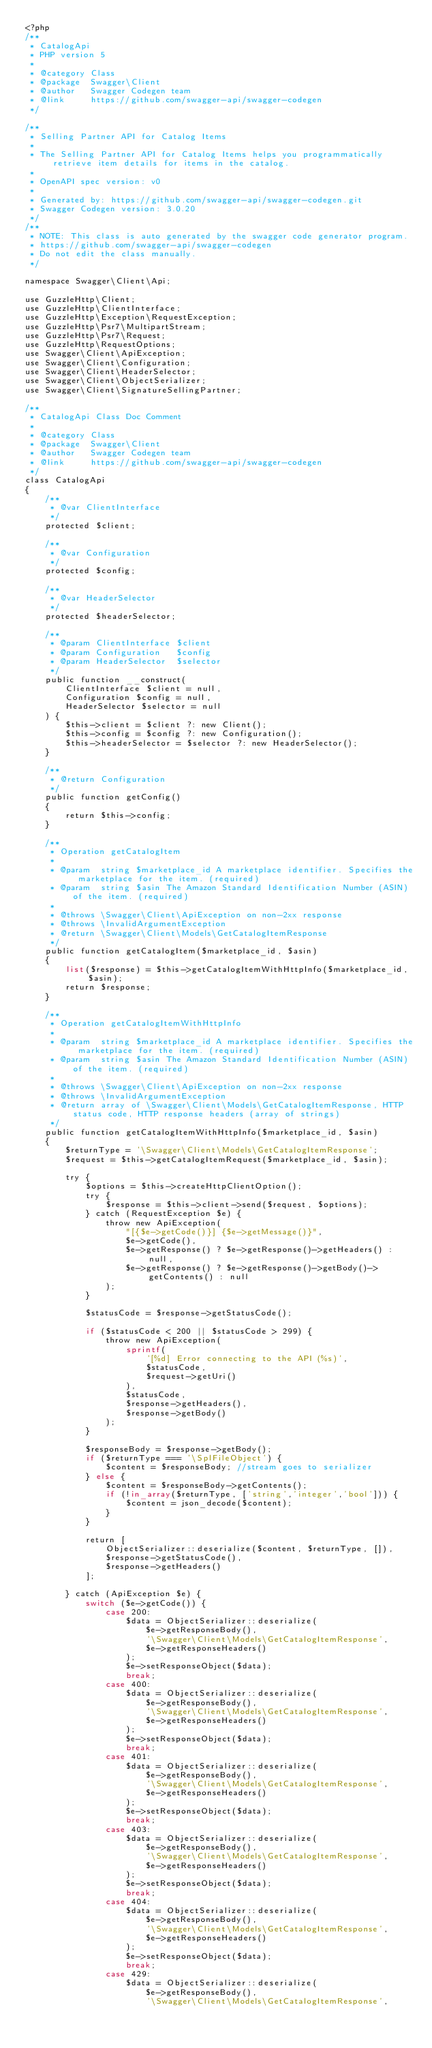Convert code to text. <code><loc_0><loc_0><loc_500><loc_500><_PHP_><?php
/**
 * CatalogApi
 * PHP version 5
 *
 * @category Class
 * @package  Swagger\Client
 * @author   Swagger Codegen team
 * @link     https://github.com/swagger-api/swagger-codegen
 */

/**
 * Selling Partner API for Catalog Items
 *
 * The Selling Partner API for Catalog Items helps you programmatically retrieve item details for items in the catalog.
 *
 * OpenAPI spec version: v0
 * 
 * Generated by: https://github.com/swagger-api/swagger-codegen.git
 * Swagger Codegen version: 3.0.20
 */
/**
 * NOTE: This class is auto generated by the swagger code generator program.
 * https://github.com/swagger-api/swagger-codegen
 * Do not edit the class manually.
 */

namespace Swagger\Client\Api;

use GuzzleHttp\Client;
use GuzzleHttp\ClientInterface;
use GuzzleHttp\Exception\RequestException;
use GuzzleHttp\Psr7\MultipartStream;
use GuzzleHttp\Psr7\Request;
use GuzzleHttp\RequestOptions;
use Swagger\Client\ApiException;
use Swagger\Client\Configuration;
use Swagger\Client\HeaderSelector;
use Swagger\Client\ObjectSerializer;
use Swagger\Client\SignatureSellingPartner;

/**
 * CatalogApi Class Doc Comment
 *
 * @category Class
 * @package  Swagger\Client
 * @author   Swagger Codegen team
 * @link     https://github.com/swagger-api/swagger-codegen
 */
class CatalogApi
{
    /**
     * @var ClientInterface
     */
    protected $client;

    /**
     * @var Configuration
     */
    protected $config;

    /**
     * @var HeaderSelector
     */
    protected $headerSelector;

    /**
     * @param ClientInterface $client
     * @param Configuration   $config
     * @param HeaderSelector  $selector
     */
    public function __construct(
        ClientInterface $client = null,
        Configuration $config = null,
        HeaderSelector $selector = null
    ) {
        $this->client = $client ?: new Client();
        $this->config = $config ?: new Configuration();
        $this->headerSelector = $selector ?: new HeaderSelector();
    }

    /**
     * @return Configuration
     */
    public function getConfig()
    {
        return $this->config;
    }

    /**
     * Operation getCatalogItem
     *
     * @param  string $marketplace_id A marketplace identifier. Specifies the marketplace for the item. (required)
     * @param  string $asin The Amazon Standard Identification Number (ASIN) of the item. (required)
     *
     * @throws \Swagger\Client\ApiException on non-2xx response
     * @throws \InvalidArgumentException
     * @return \Swagger\Client\Models\GetCatalogItemResponse
     */
    public function getCatalogItem($marketplace_id, $asin)
    {
        list($response) = $this->getCatalogItemWithHttpInfo($marketplace_id, $asin);
        return $response;
    }

    /**
     * Operation getCatalogItemWithHttpInfo
     *
     * @param  string $marketplace_id A marketplace identifier. Specifies the marketplace for the item. (required)
     * @param  string $asin The Amazon Standard Identification Number (ASIN) of the item. (required)
     *
     * @throws \Swagger\Client\ApiException on non-2xx response
     * @throws \InvalidArgumentException
     * @return array of \Swagger\Client\Models\GetCatalogItemResponse, HTTP status code, HTTP response headers (array of strings)
     */
    public function getCatalogItemWithHttpInfo($marketplace_id, $asin)
    {
        $returnType = '\Swagger\Client\Models\GetCatalogItemResponse';
        $request = $this->getCatalogItemRequest($marketplace_id, $asin);

        try {
            $options = $this->createHttpClientOption();
            try {
                $response = $this->client->send($request, $options);
            } catch (RequestException $e) {
                throw new ApiException(
                    "[{$e->getCode()}] {$e->getMessage()}",
                    $e->getCode(),
                    $e->getResponse() ? $e->getResponse()->getHeaders() : null,
                    $e->getResponse() ? $e->getResponse()->getBody()->getContents() : null
                );
            }

            $statusCode = $response->getStatusCode();

            if ($statusCode < 200 || $statusCode > 299) {
                throw new ApiException(
                    sprintf(
                        '[%d] Error connecting to the API (%s)',
                        $statusCode,
                        $request->getUri()
                    ),
                    $statusCode,
                    $response->getHeaders(),
                    $response->getBody()
                );
            }

            $responseBody = $response->getBody();
            if ($returnType === '\SplFileObject') {
                $content = $responseBody; //stream goes to serializer
            } else {
                $content = $responseBody->getContents();
                if (!in_array($returnType, ['string','integer','bool'])) {
                    $content = json_decode($content);
                }
            }

            return [
                ObjectSerializer::deserialize($content, $returnType, []),
                $response->getStatusCode(),
                $response->getHeaders()
            ];

        } catch (ApiException $e) {
            switch ($e->getCode()) {
                case 200:
                    $data = ObjectSerializer::deserialize(
                        $e->getResponseBody(),
                        '\Swagger\Client\Models\GetCatalogItemResponse',
                        $e->getResponseHeaders()
                    );
                    $e->setResponseObject($data);
                    break;
                case 400:
                    $data = ObjectSerializer::deserialize(
                        $e->getResponseBody(),
                        '\Swagger\Client\Models\GetCatalogItemResponse',
                        $e->getResponseHeaders()
                    );
                    $e->setResponseObject($data);
                    break;
                case 401:
                    $data = ObjectSerializer::deserialize(
                        $e->getResponseBody(),
                        '\Swagger\Client\Models\GetCatalogItemResponse',
                        $e->getResponseHeaders()
                    );
                    $e->setResponseObject($data);
                    break;
                case 403:
                    $data = ObjectSerializer::deserialize(
                        $e->getResponseBody(),
                        '\Swagger\Client\Models\GetCatalogItemResponse',
                        $e->getResponseHeaders()
                    );
                    $e->setResponseObject($data);
                    break;
                case 404:
                    $data = ObjectSerializer::deserialize(
                        $e->getResponseBody(),
                        '\Swagger\Client\Models\GetCatalogItemResponse',
                        $e->getResponseHeaders()
                    );
                    $e->setResponseObject($data);
                    break;
                case 429:
                    $data = ObjectSerializer::deserialize(
                        $e->getResponseBody(),
                        '\Swagger\Client\Models\GetCatalogItemResponse',</code> 